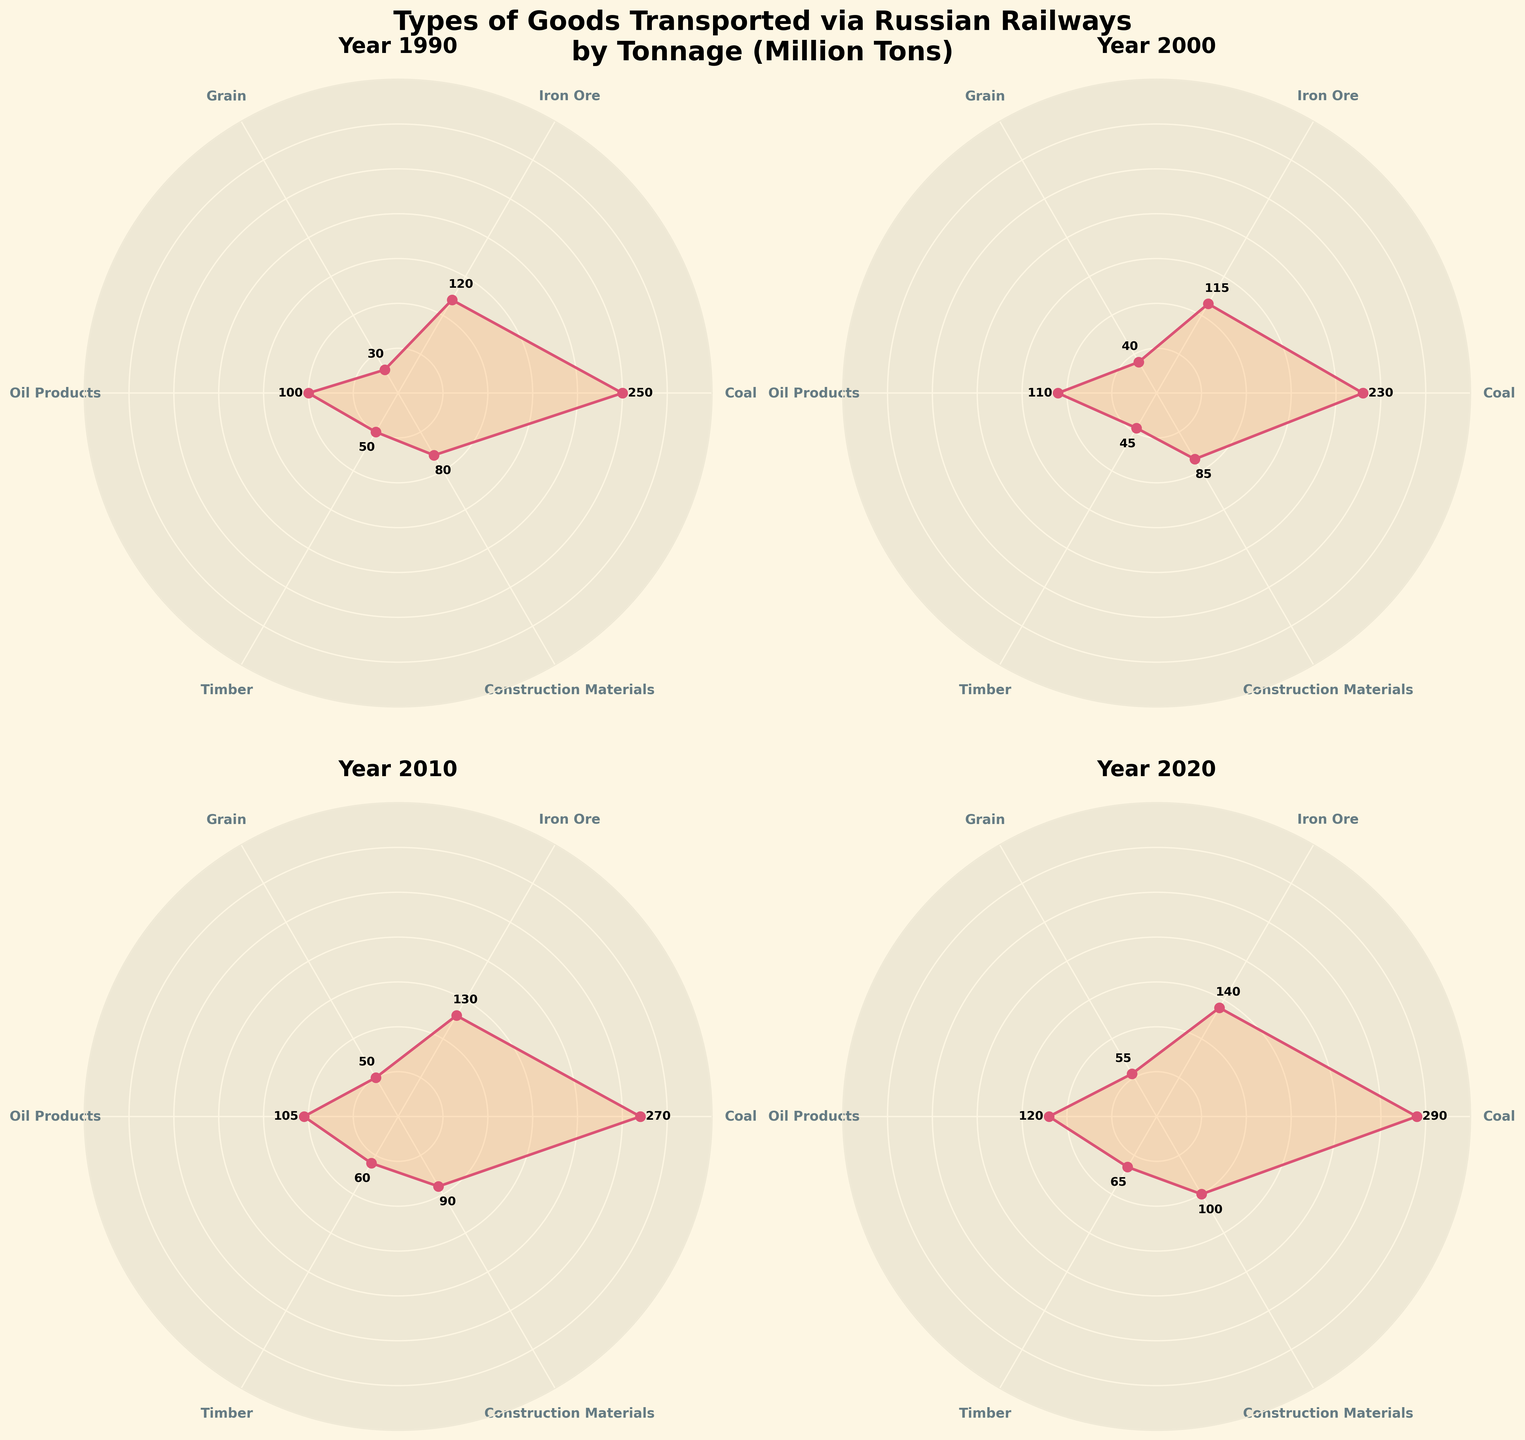What year had the highest tonnage of coal transported? The 2020 subplot shows the highest tonnage value for coal among all years.
Answer: 2020 What is the difference in tonnage of grain transported between 1990 and 2020? From the 1990 subplot, grain tonnage is 30 million tons. In 2020, it is 55 million tons. The difference is 55 - 30 = 25 million tons.
Answer: 25 million tons Which year had the lowest tonnage of timber transported? By comparing the subplots, the year 2000 shows the lowest timber tonnage, which is 45 million tons.
Answer: 2000 In which year was the total tonnage the greatest and what was its value? Calculate the total tonnage for each year by summing up all categories. Summing up the values for 2020 (290 + 140 + 55 + 120 + 65 + 100 = 770 million tons) gives the year with the greatest total tonnage.
Answer: 2020, 770 million tons How much did the tonnage of oil products transported increase from 1990 to 2020? From 1990, the tonnage of oil products was 100 million tons. In 2020, it was 120 million tons. Thus, the increase is 120 - 100 = 20 million tons.
Answer: 20 million tons Which category’s tonnage remained most consistent across the years? By comparing the subplots, the iron ore values (120, 115, 130, 140) show relatively smaller variations compared to other categories.
Answer: Iron Ore Which year had the highest number of tonnage categories surpassing 100 million tons? Examine each year subplot; 2020 has the most categories above 100 million tons (coal, iron ore, oil products, construction materials).
Answer: 2020 What is the average tonnage of construction materials transported over the four decades? Average = (80 + 85 + 90 + 100) / 4 = 88.75 million tons.
Answer: 88.75 million tons 